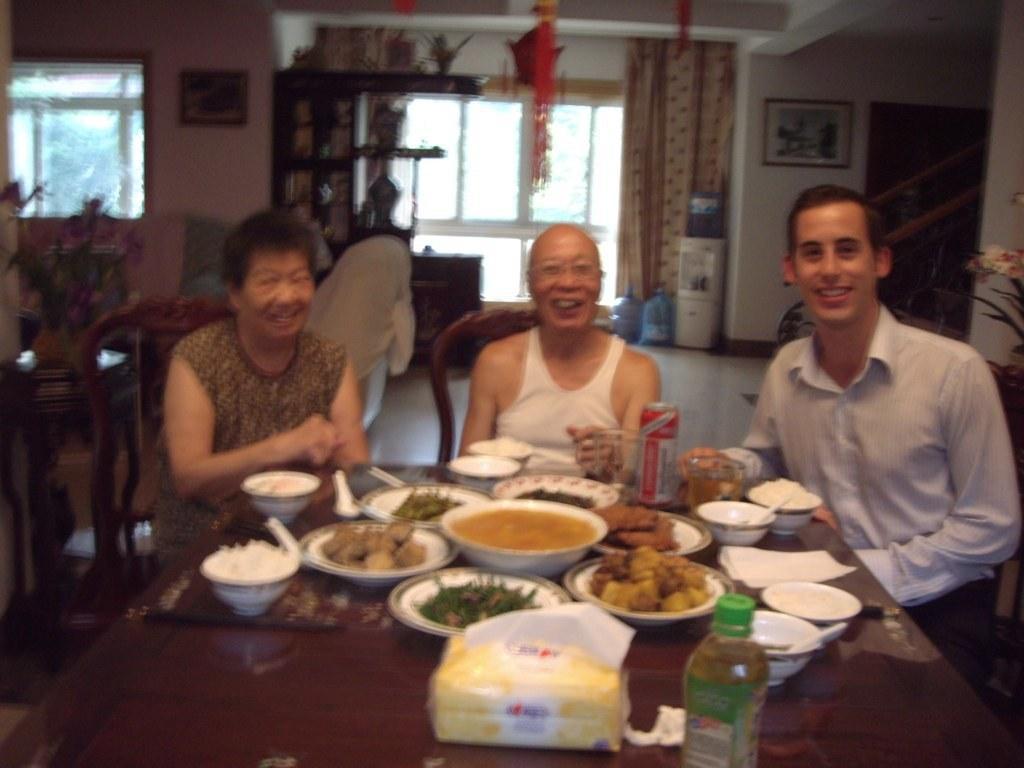Please provide a concise description of this image. This picture shows three men seated on the chairs and we see some food items in the bowls on the table 